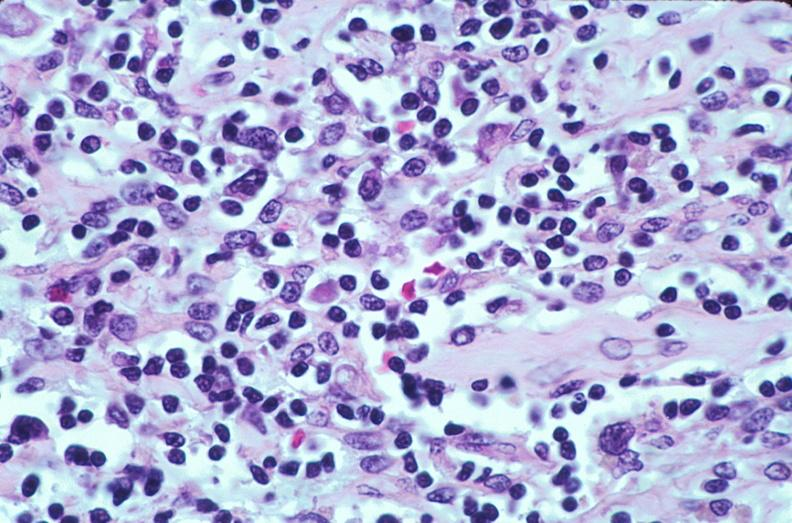what does this image show?
Answer the question using a single word or phrase. Lymph nodes 